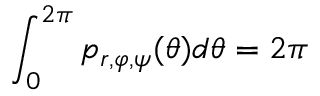Convert formula to latex. <formula><loc_0><loc_0><loc_500><loc_500>\int _ { 0 } ^ { 2 \pi } p _ { r , \varphi , \psi } ( \theta ) d \theta = 2 \pi</formula> 